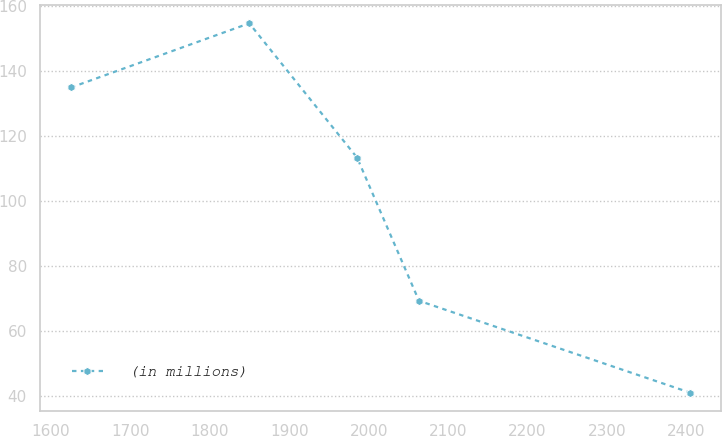<chart> <loc_0><loc_0><loc_500><loc_500><line_chart><ecel><fcel>(in millions)<nl><fcel>1625.27<fcel>134.98<nl><fcel>1849.62<fcel>154.74<nl><fcel>1985.39<fcel>113.36<nl><fcel>2063.28<fcel>69.3<nl><fcel>2404.18<fcel>41.05<nl></chart> 